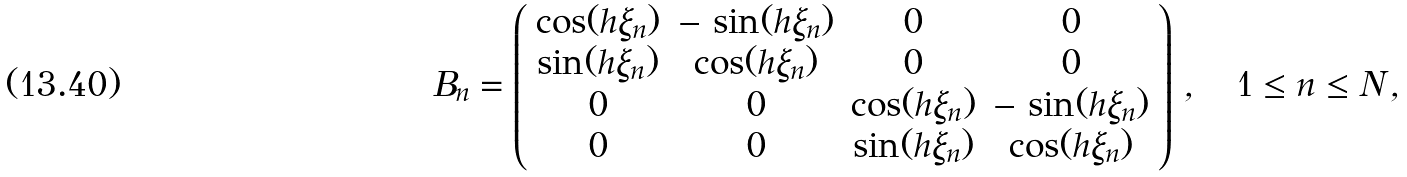Convert formula to latex. <formula><loc_0><loc_0><loc_500><loc_500>B _ { n } = \left ( \begin{array} { c c c c } \cos ( h \xi _ { n } ) & - \, \sin ( h \xi _ { n } ) & 0 & 0 \\ \sin ( h \xi _ { n } ) & \cos ( h \xi _ { n } ) & 0 & 0 \\ 0 & 0 & \cos ( h \xi _ { n } ) & - \, \sin ( h \xi _ { n } ) \\ 0 & 0 & \sin ( h \xi _ { n } ) & \cos ( h \xi _ { n } ) \end{array} \right ) \, , \quad 1 \leq n \leq N \, ,</formula> 